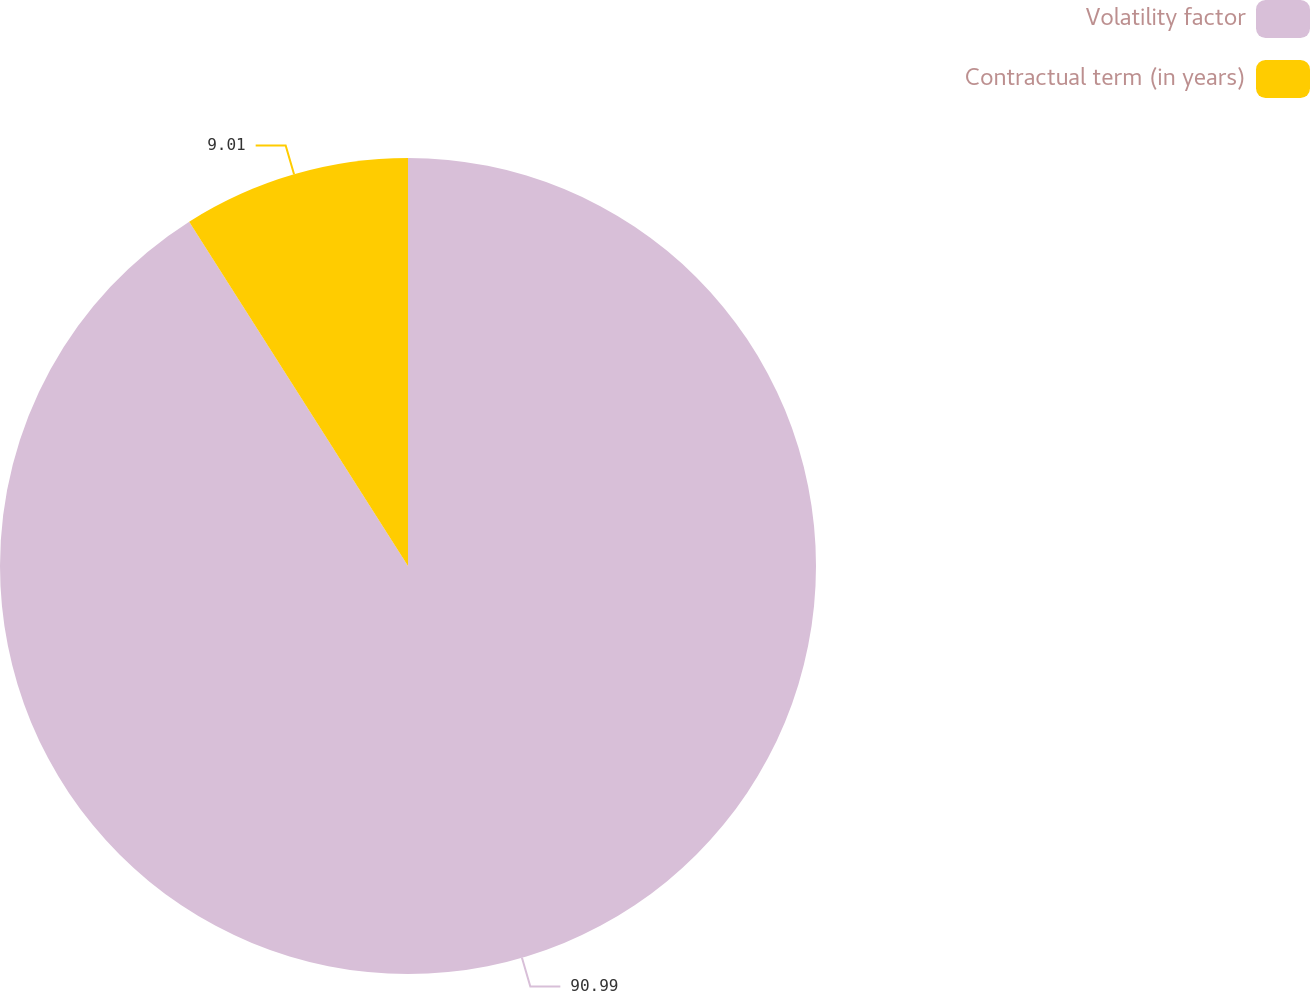Convert chart to OTSL. <chart><loc_0><loc_0><loc_500><loc_500><pie_chart><fcel>Volatility factor<fcel>Contractual term (in years)<nl><fcel>90.99%<fcel>9.01%<nl></chart> 